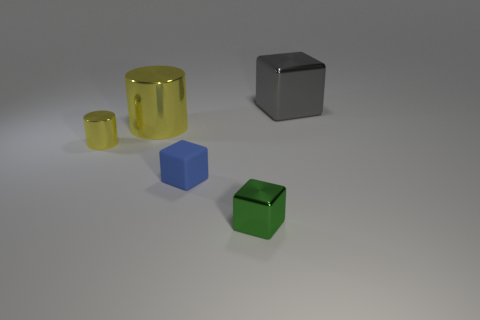Is the big shiny block the same color as the small rubber cube? The large shiny block is a neutral gray, while the small rubber cube appears to be a vibrant green. Despite the contrast in size and material finish, their colors are distinctly different. 